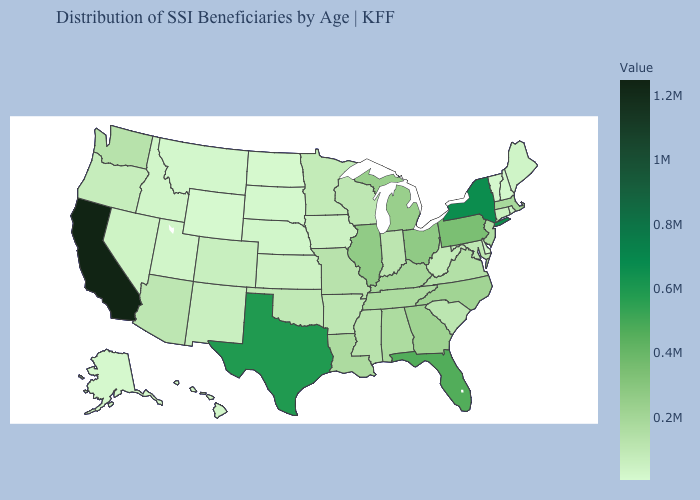Does Arizona have the highest value in the USA?
Short answer required. No. Among the states that border Florida , does Georgia have the lowest value?
Quick response, please. No. Among the states that border New Mexico , does Texas have the highest value?
Keep it brief. Yes. Does Wyoming have the lowest value in the USA?
Concise answer only. Yes. Which states hav the highest value in the Northeast?
Answer briefly. New York. 